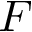Convert formula to latex. <formula><loc_0><loc_0><loc_500><loc_500>F</formula> 